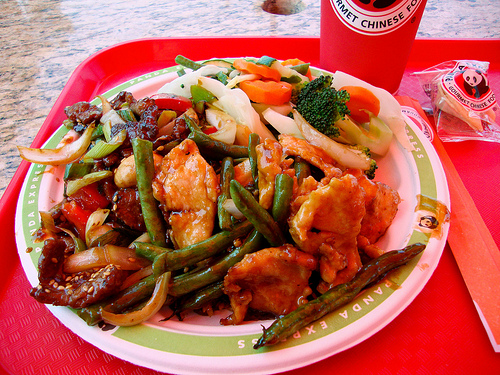<image>
Can you confirm if the plate is under the food? Yes. The plate is positioned underneath the food, with the food above it in the vertical space. 